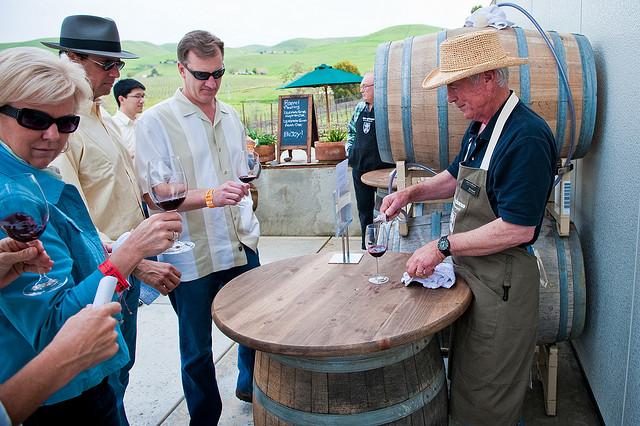How many wooden barrels do you see?
Be succinct. 3. Is everyone drinking red wine?
Answer briefly. Yes. Is the woman in the blue shirt wearing sunglasses?
Quick response, please. Yes. 